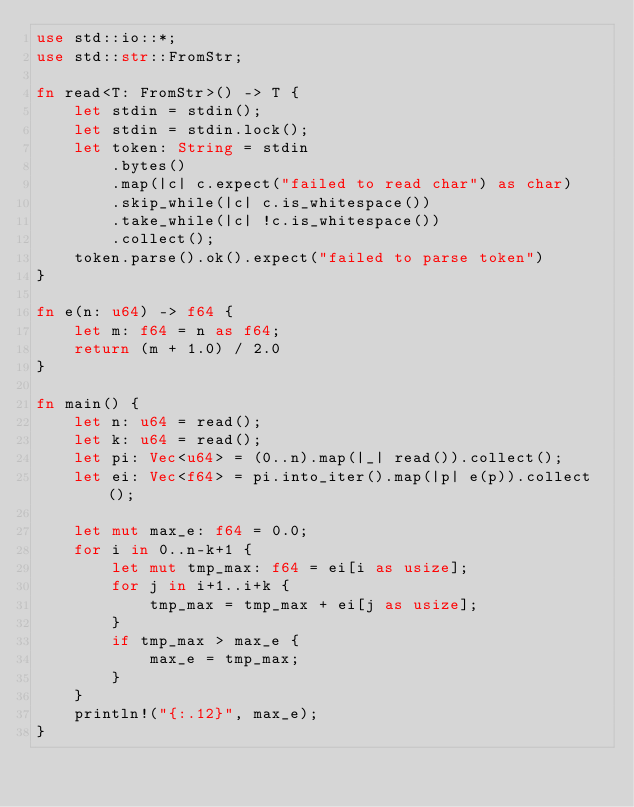Convert code to text. <code><loc_0><loc_0><loc_500><loc_500><_Rust_>use std::io::*;
use std::str::FromStr;

fn read<T: FromStr>() -> T {
    let stdin = stdin();
    let stdin = stdin.lock();
    let token: String = stdin
        .bytes()
        .map(|c| c.expect("failed to read char") as char) 
        .skip_while(|c| c.is_whitespace())
        .take_while(|c| !c.is_whitespace())
        .collect();
    token.parse().ok().expect("failed to parse token")
}

fn e(n: u64) -> f64 {
    let m: f64 = n as f64;
    return (m + 1.0) / 2.0
}

fn main() {
    let n: u64 = read();
    let k: u64 = read();
    let pi: Vec<u64> = (0..n).map(|_| read()).collect();
    let ei: Vec<f64> = pi.into_iter().map(|p| e(p)).collect();

    let mut max_e: f64 = 0.0;
    for i in 0..n-k+1 {
        let mut tmp_max: f64 = ei[i as usize];
        for j in i+1..i+k {
            tmp_max = tmp_max + ei[j as usize];
        }
        if tmp_max > max_e {
            max_e = tmp_max;
        }
    }
    println!("{:.12}", max_e);
}
</code> 